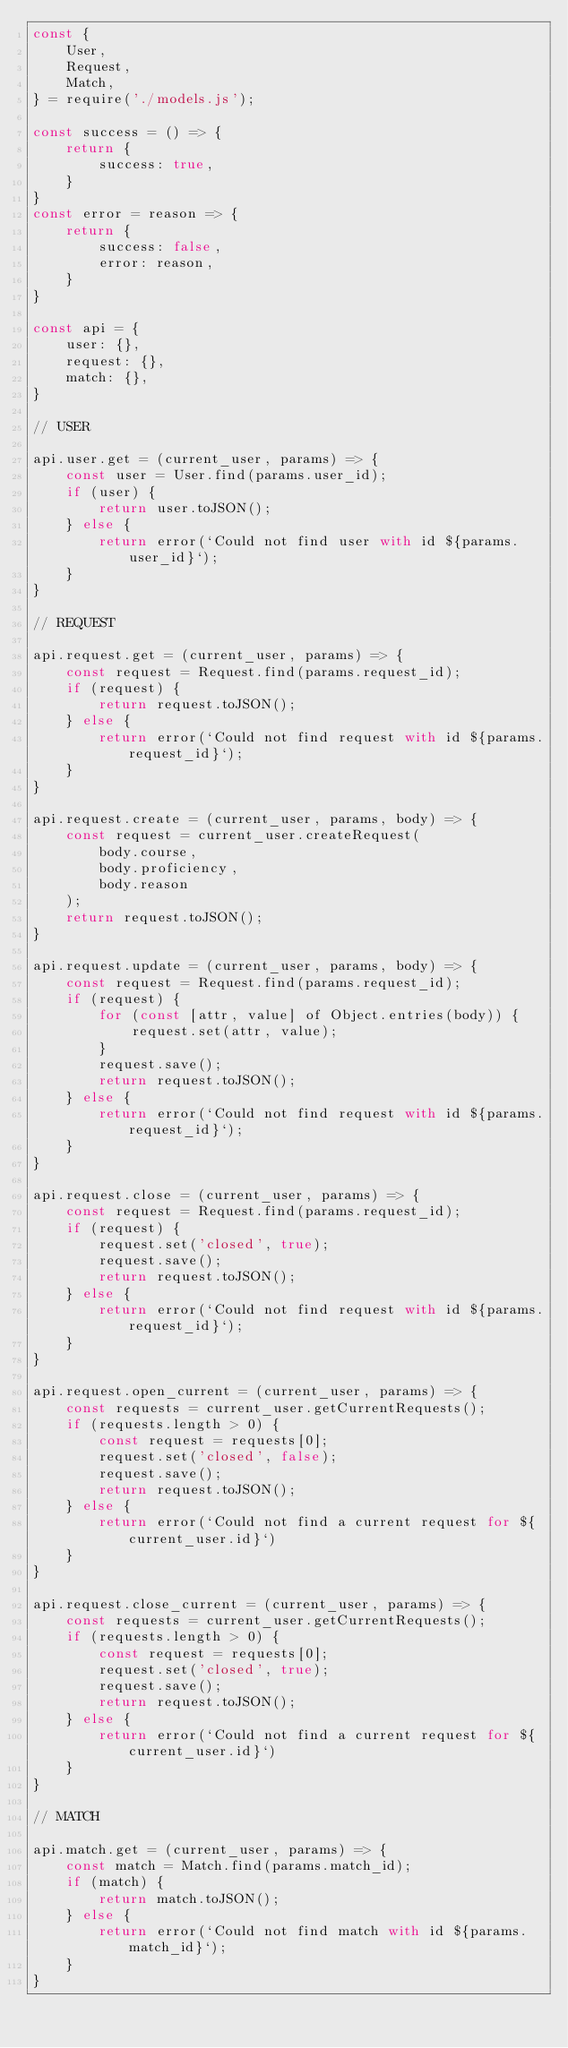<code> <loc_0><loc_0><loc_500><loc_500><_JavaScript_>const {
    User,
    Request,
    Match,
} = require('./models.js');

const success = () => {
    return {
        success: true,
    }
}
const error = reason => {
    return {
        success: false,
        error: reason,
    }
}

const api = {
    user: {},
    request: {},
    match: {},
}

// USER

api.user.get = (current_user, params) => {
    const user = User.find(params.user_id);
    if (user) {
        return user.toJSON();
    } else {
        return error(`Could not find user with id ${params.user_id}`);
    }
}

// REQUEST

api.request.get = (current_user, params) => {
    const request = Request.find(params.request_id);
    if (request) {
        return request.toJSON();
    } else {
        return error(`Could not find request with id ${params.request_id}`);
    }
}

api.request.create = (current_user, params, body) => {
    const request = current_user.createRequest(
        body.course,
        body.proficiency,
        body.reason
    );
    return request.toJSON();
}

api.request.update = (current_user, params, body) => {
    const request = Request.find(params.request_id);
    if (request) {
        for (const [attr, value] of Object.entries(body)) {
            request.set(attr, value);
        }
        request.save();
        return request.toJSON();
    } else {
        return error(`Could not find request with id ${params.request_id}`);
    }
}

api.request.close = (current_user, params) => {
    const request = Request.find(params.request_id);
    if (request) {
        request.set('closed', true);
        request.save();
        return request.toJSON();
    } else {
        return error(`Could not find request with id ${params.request_id}`);
    }
}

api.request.open_current = (current_user, params) => {
    const requests = current_user.getCurrentRequests();
    if (requests.length > 0) {
        const request = requests[0];
        request.set('closed', false);
        request.save();
        return request.toJSON();
    } else {
        return error(`Could not find a current request for ${current_user.id}`)
    }
}

api.request.close_current = (current_user, params) => {
    const requests = current_user.getCurrentRequests();
    if (requests.length > 0) {
        const request = requests[0];
        request.set('closed', true);
        request.save();
        return request.toJSON();
    } else {
        return error(`Could not find a current request for ${current_user.id}`)
    }
}

// MATCH

api.match.get = (current_user, params) => {
    const match = Match.find(params.match_id);
    if (match) {
        return match.toJSON();
    } else {
        return error(`Could not find match with id ${params.match_id}`);
    }
}
</code> 